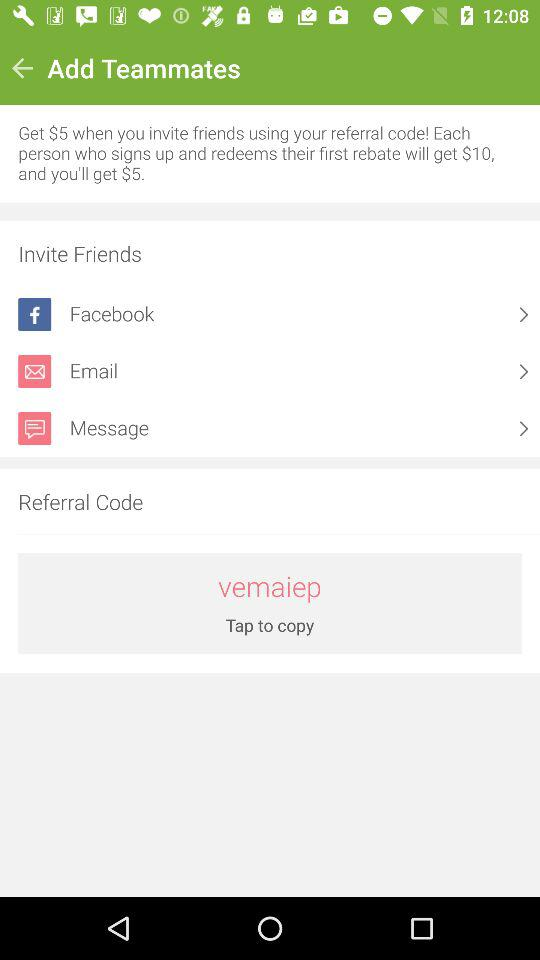How many ways are there to invite friends?
Answer the question using a single word or phrase. 3 